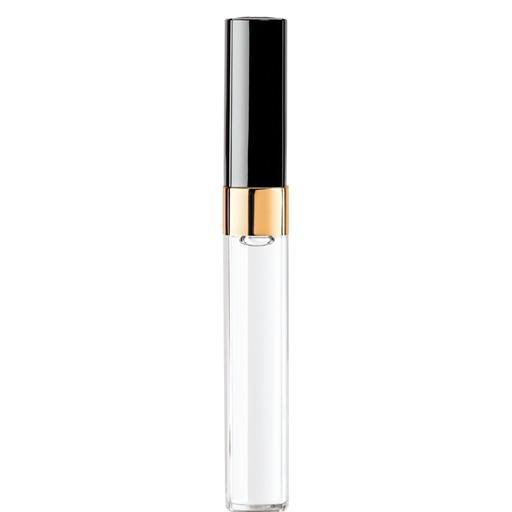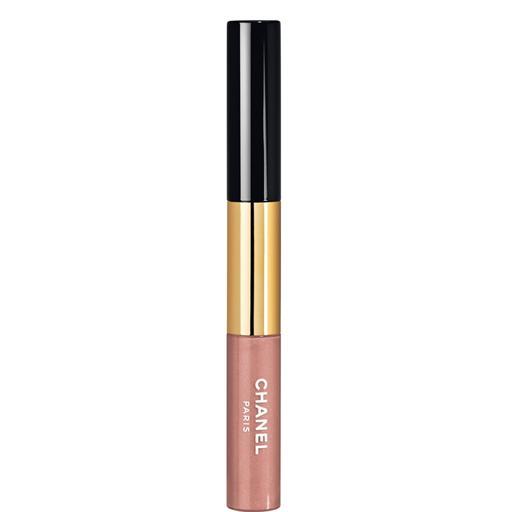The first image is the image on the left, the second image is the image on the right. Considering the images on both sides, is "There are at most 2 lipsticks in the image pair" valid? Answer yes or no. Yes. The first image is the image on the left, the second image is the image on the right. Assess this claim about the two images: "All of the lipsticks shown are arranged parallel to one another, both within and across the two images.". Correct or not? Answer yes or no. Yes. 